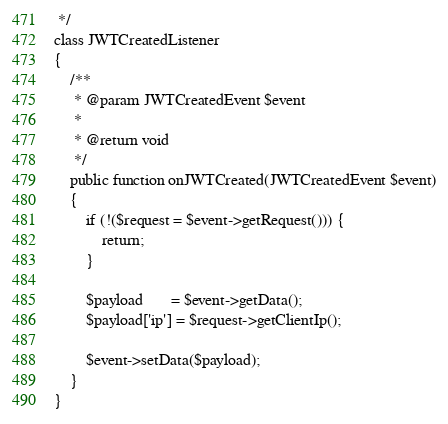<code> <loc_0><loc_0><loc_500><loc_500><_PHP_> */
class JWTCreatedListener
{
    /**
     * @param JWTCreatedEvent $event
     *
     * @return void
     */
    public function onJWTCreated(JWTCreatedEvent $event)
    {
        if (!($request = $event->getRequest())) {
            return;
        }

        $payload       = $event->getData();
        $payload['ip'] = $request->getClientIp();

        $event->setData($payload);
    }
}
</code> 